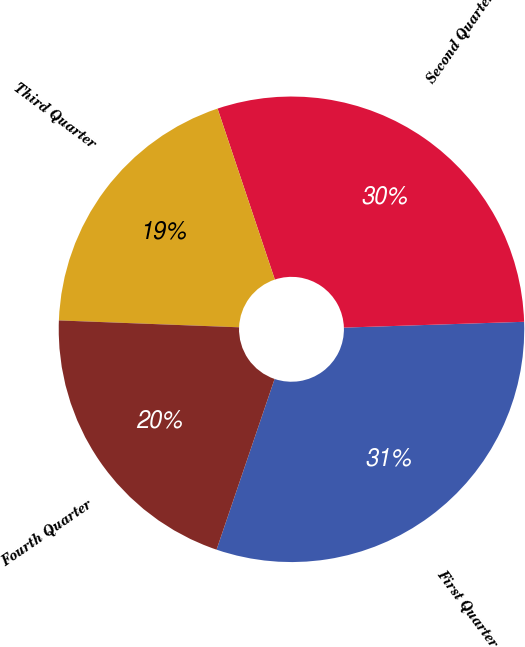Convert chart to OTSL. <chart><loc_0><loc_0><loc_500><loc_500><pie_chart><fcel>First Quarter<fcel>Second Quarter<fcel>Third Quarter<fcel>Fourth Quarter<nl><fcel>30.73%<fcel>29.63%<fcel>19.25%<fcel>20.39%<nl></chart> 